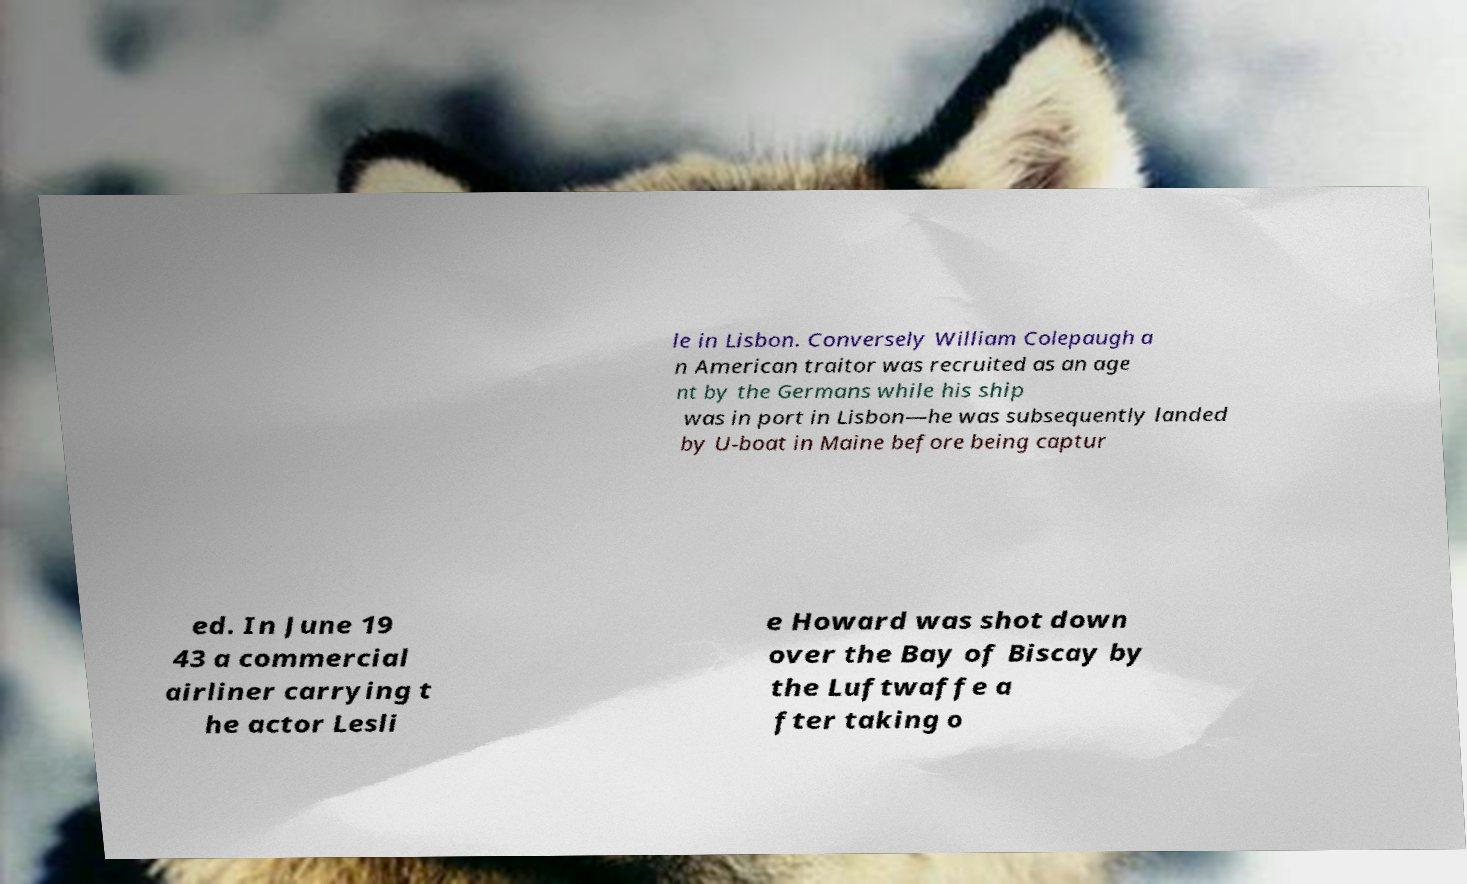Please read and relay the text visible in this image. What does it say? le in Lisbon. Conversely William Colepaugh a n American traitor was recruited as an age nt by the Germans while his ship was in port in Lisbon—he was subsequently landed by U-boat in Maine before being captur ed. In June 19 43 a commercial airliner carrying t he actor Lesli e Howard was shot down over the Bay of Biscay by the Luftwaffe a fter taking o 